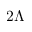Convert formula to latex. <formula><loc_0><loc_0><loc_500><loc_500>2 \Lambda</formula> 